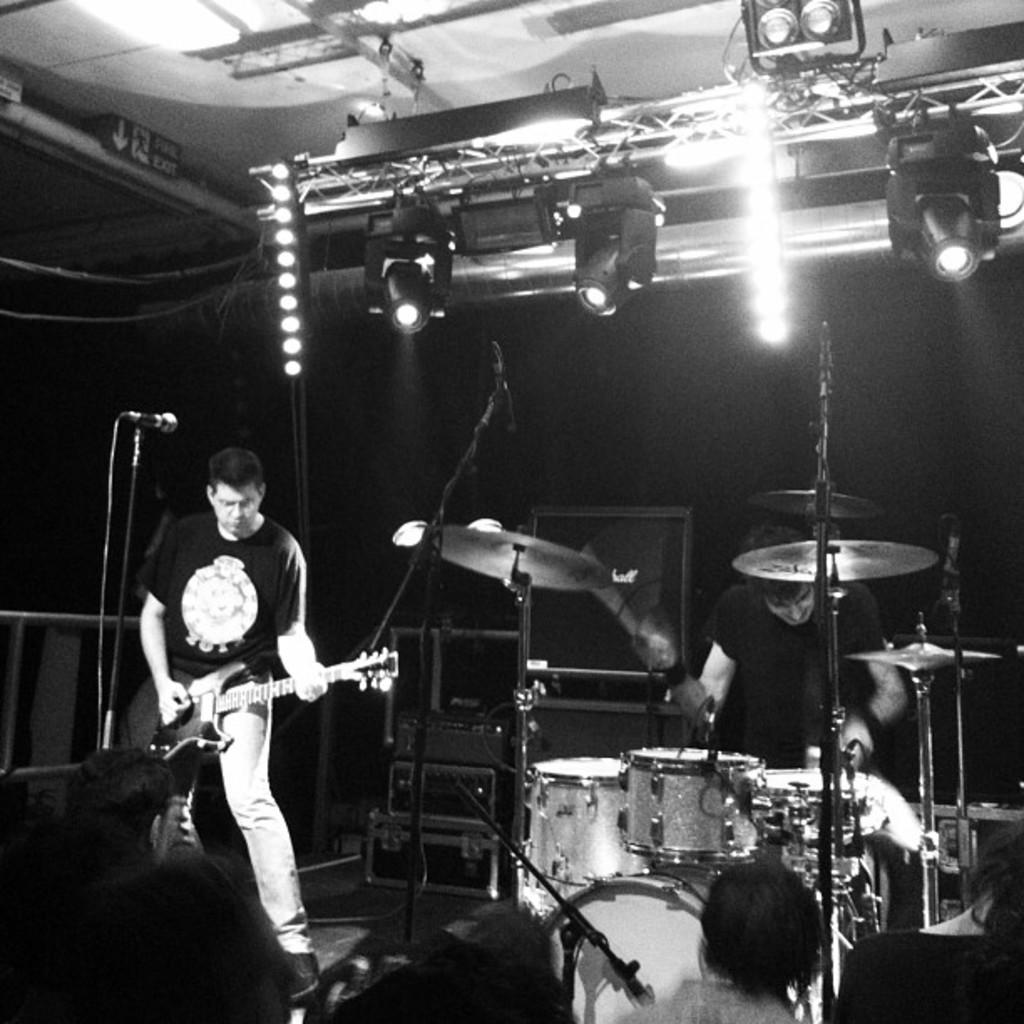How many people are in the image? There are two people in the image. What are the two people doing? The two people are holding and playing musical instruments. What else can be seen in the image besides the people and their instruments? There are speakers visible in the image. Can you describe the lighting in the image? There are lights on the roof in the image. Can you tell me how many bananas are on the island in the image? There is no island or bananas present in the image. What do the two people believe about the music they are playing? The image does not provide information about the beliefs of the two people regarding the music they are playing. 